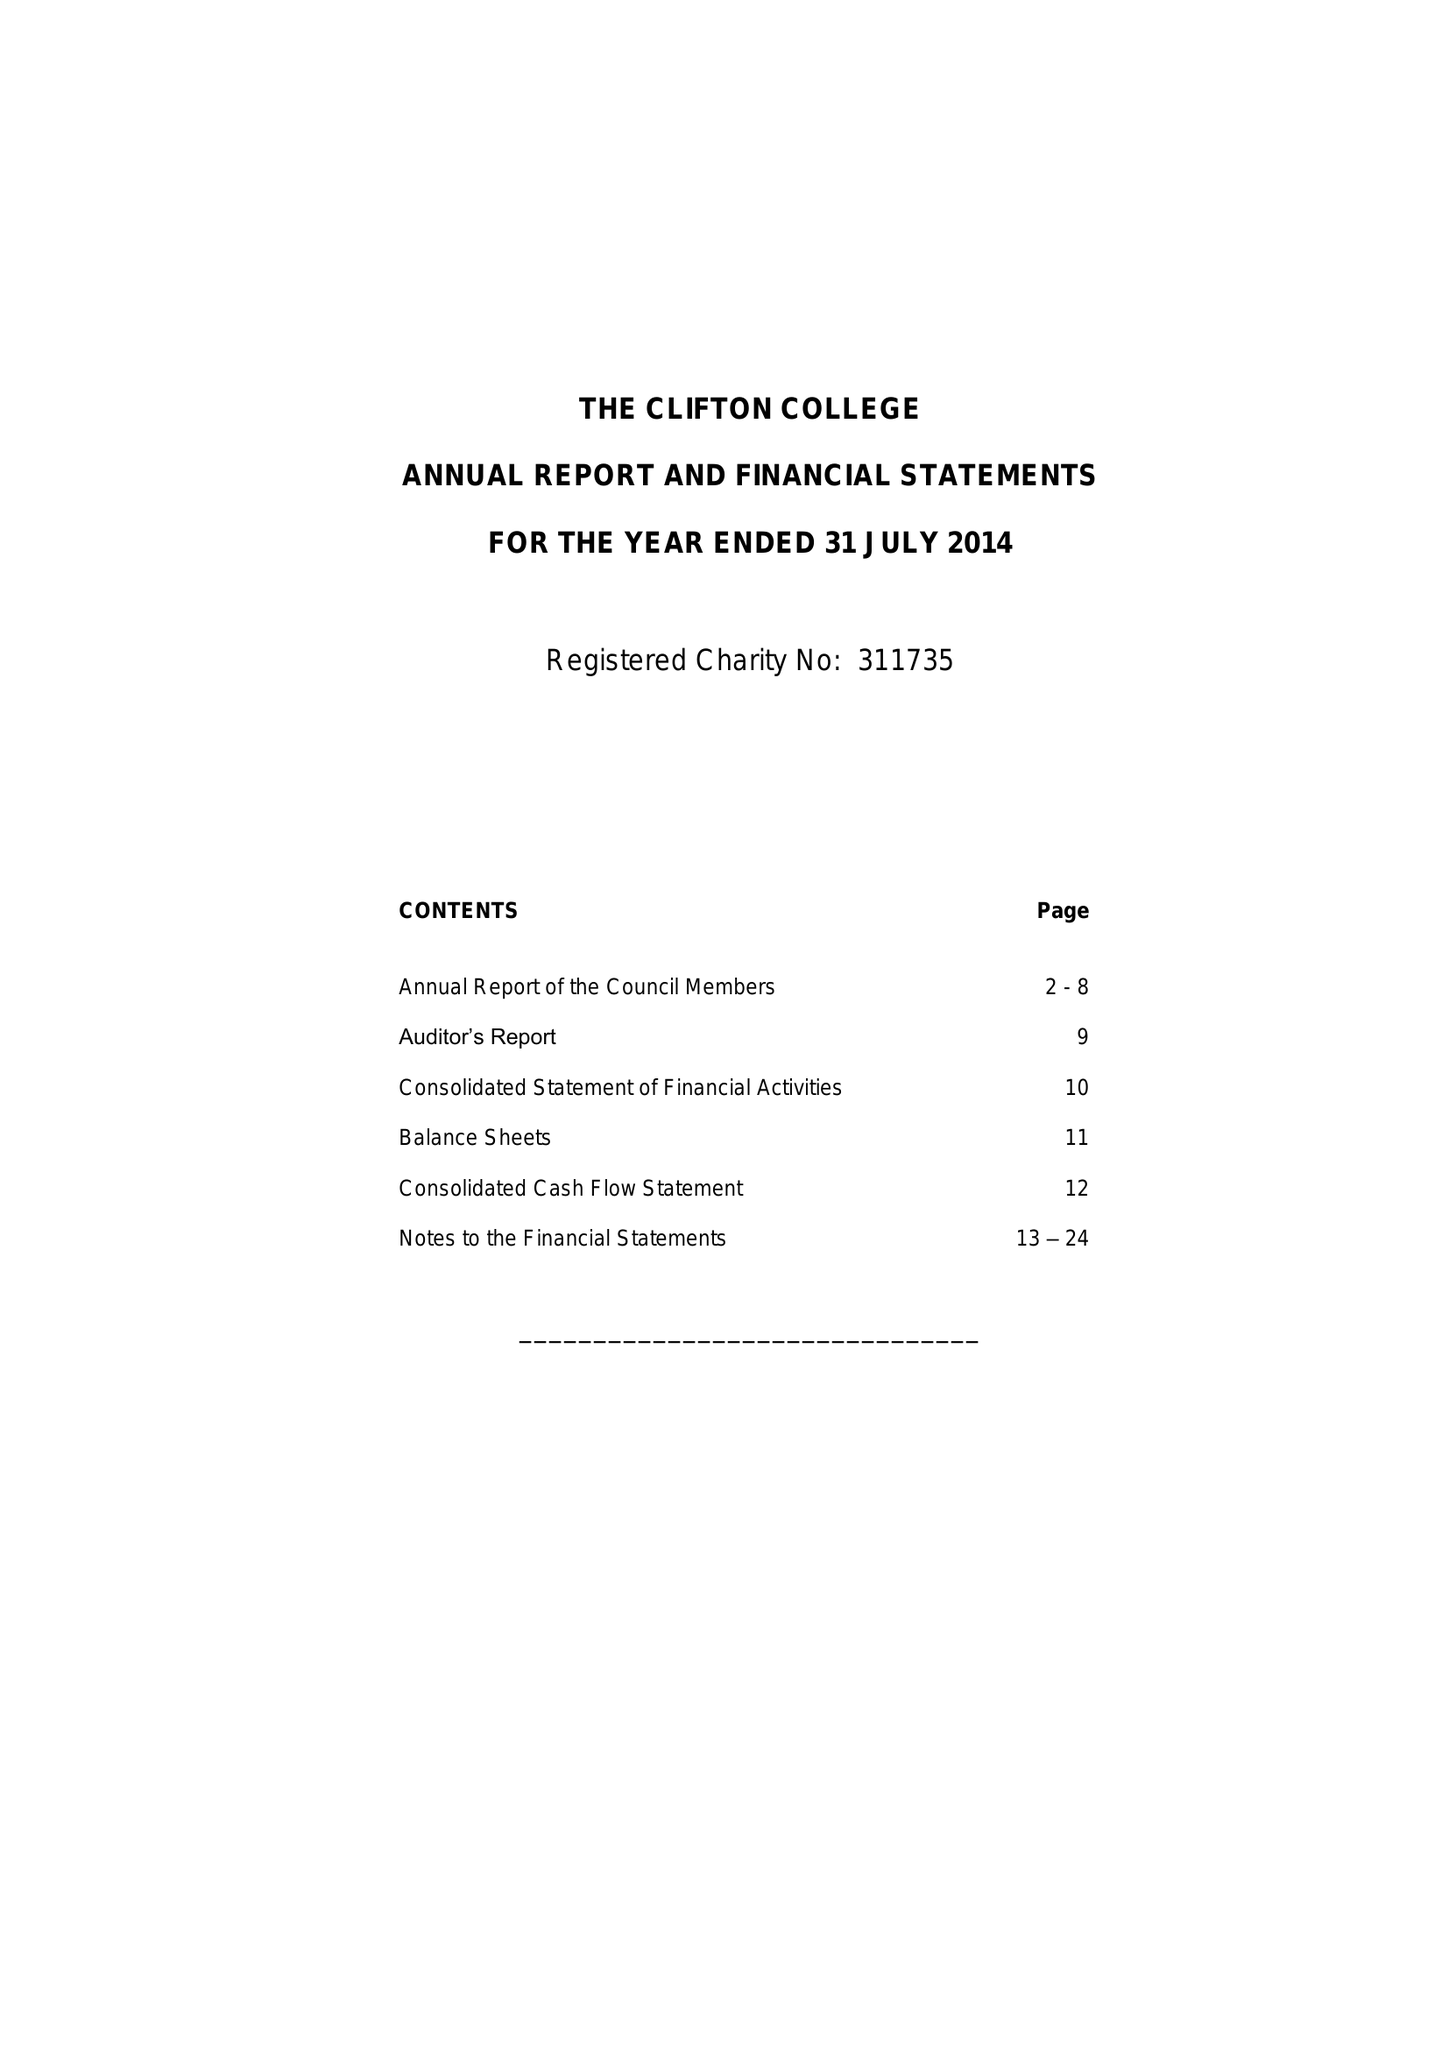What is the value for the income_annually_in_british_pounds?
Answer the question using a single word or phrase. 27151000.00 